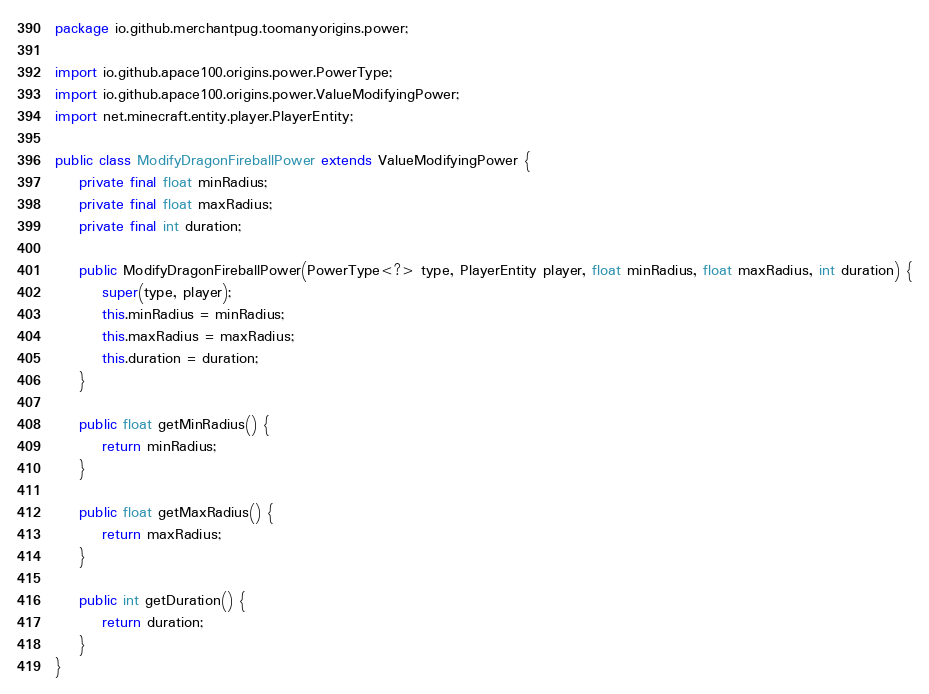<code> <loc_0><loc_0><loc_500><loc_500><_Java_>package io.github.merchantpug.toomanyorigins.power;

import io.github.apace100.origins.power.PowerType;
import io.github.apace100.origins.power.ValueModifyingPower;
import net.minecraft.entity.player.PlayerEntity;

public class ModifyDragonFireballPower extends ValueModifyingPower {
    private final float minRadius;
    private final float maxRadius;
    private final int duration;

    public ModifyDragonFireballPower(PowerType<?> type, PlayerEntity player, float minRadius, float maxRadius, int duration) {
        super(type, player);
        this.minRadius = minRadius;
        this.maxRadius = maxRadius;
        this.duration = duration;
    }

    public float getMinRadius() {
        return minRadius;
    }

    public float getMaxRadius() {
        return maxRadius;
    }

    public int getDuration() {
        return duration;
    }
}
</code> 